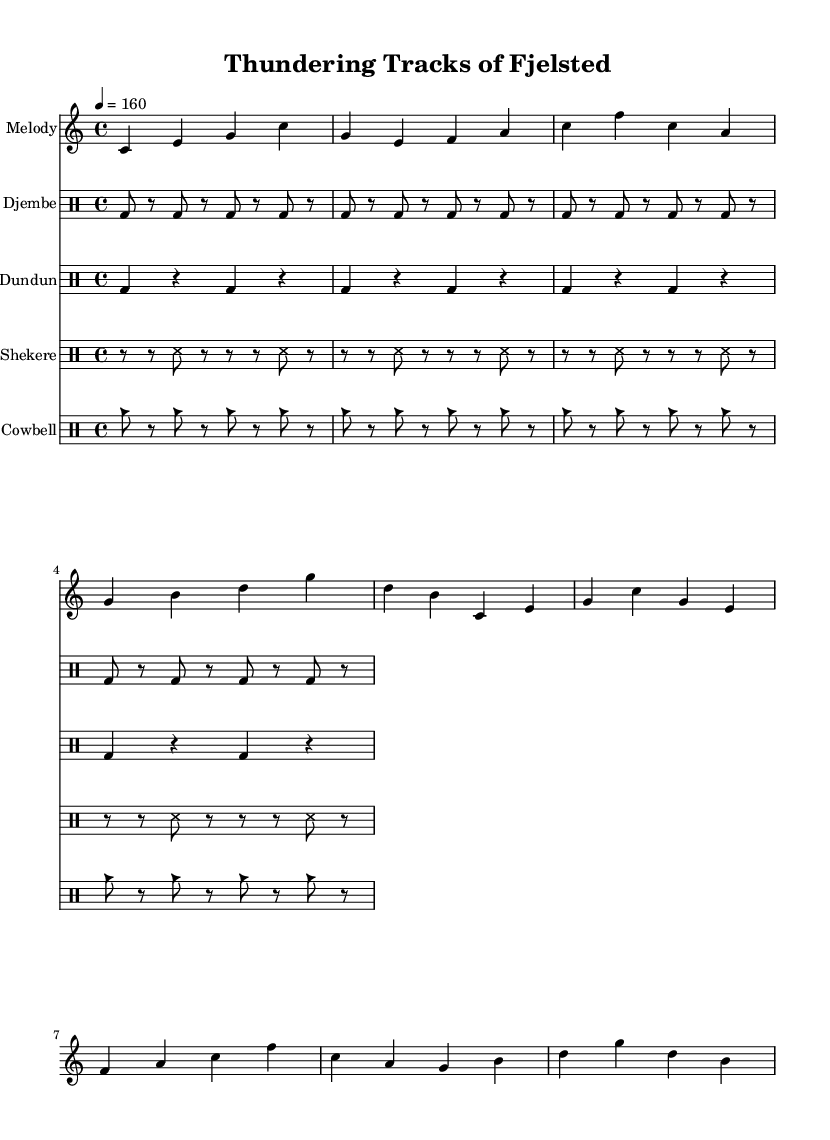What is the key signature of this music? The key signature is indicated at the beginning of the score. It shows no sharps or flats, which corresponds to C major.
Answer: C major What is the time signature of this score? The time signature is shown as 4/4 at the beginning, indicating there are four beats in each measure and the quarter note gets one beat.
Answer: 4/4 What is the tempo marking for the piece? The tempo marking is set at '4 = 160', meaning there are 160 beats per minute. This indicates a fast tempo.
Answer: 160 How many measures are there in the melody? The melody section is constructed with a repeat of two groups; each group contains four measures, which totals to 8 measures.
Answer: 8 measures Which percussion instrument has a steady pattern of bass drum hits? The djembe part clearly indicates a repeating pattern of bass drum hits in a steady sequence, which is identifiable through the notation pattern for this instrument.
Answer: Djembe What type of rhythm does the shekere part feature? The rhythm of the shekere part is characterized by a mix of rests and sixteenth notes, creating a syncopated and rhythmic texture throughout its pattern.
Answer: Syncopated 